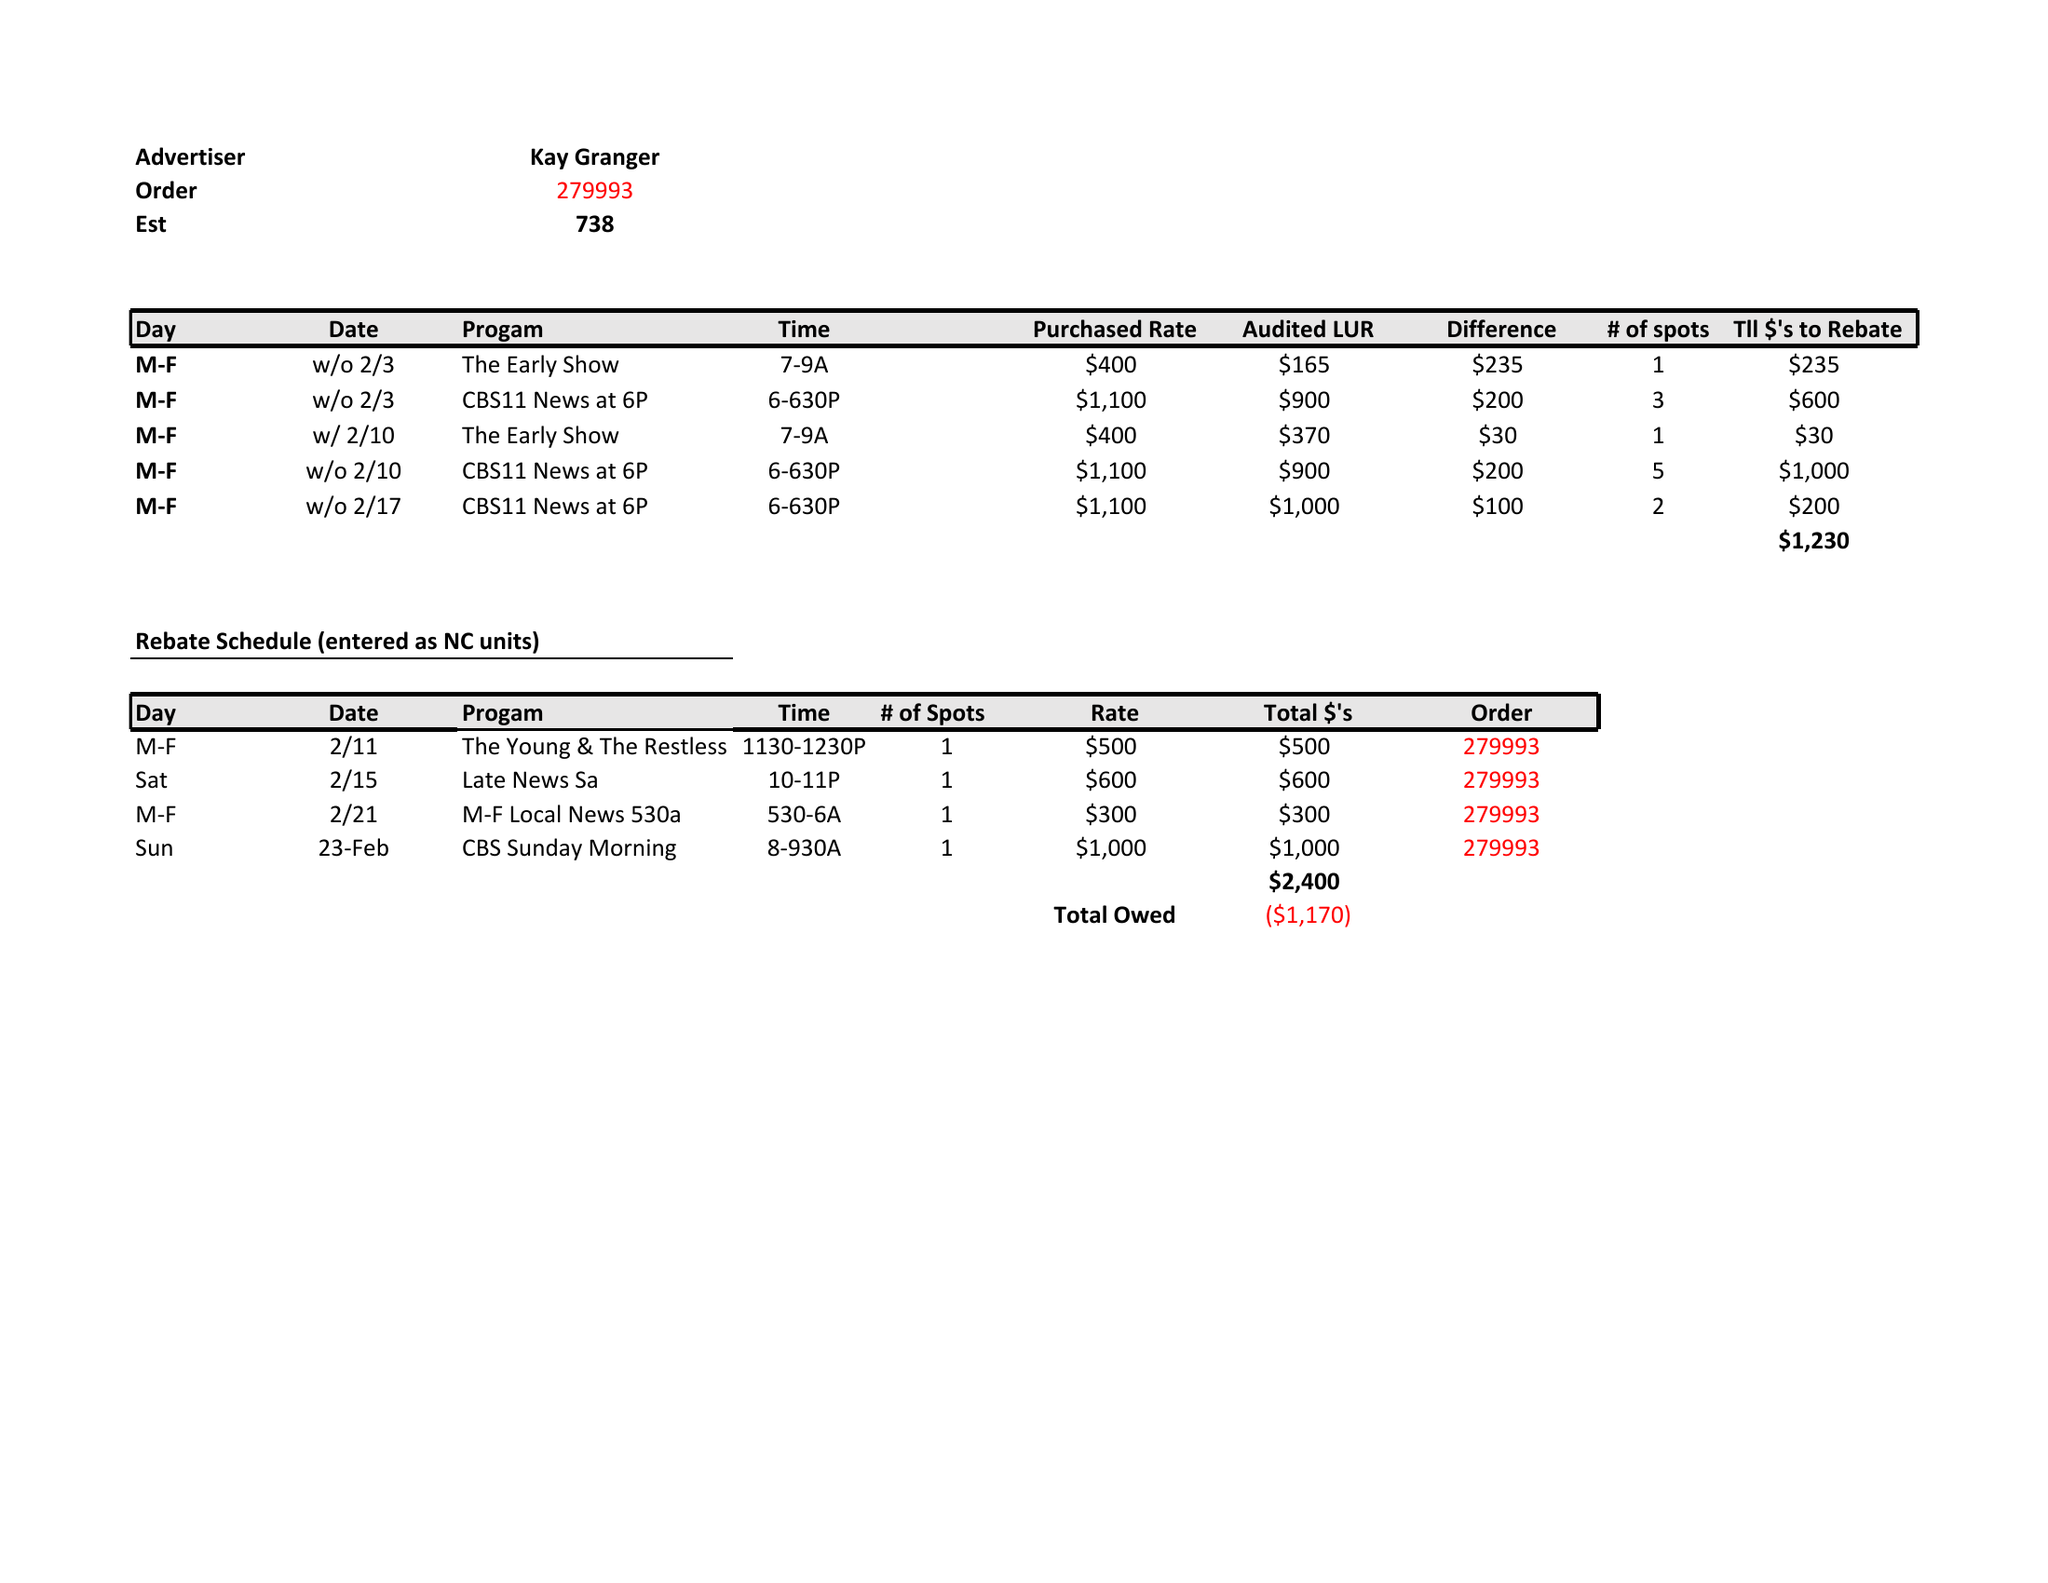What is the value for the advertiser?
Answer the question using a single word or phrase. KAY GRANGER 